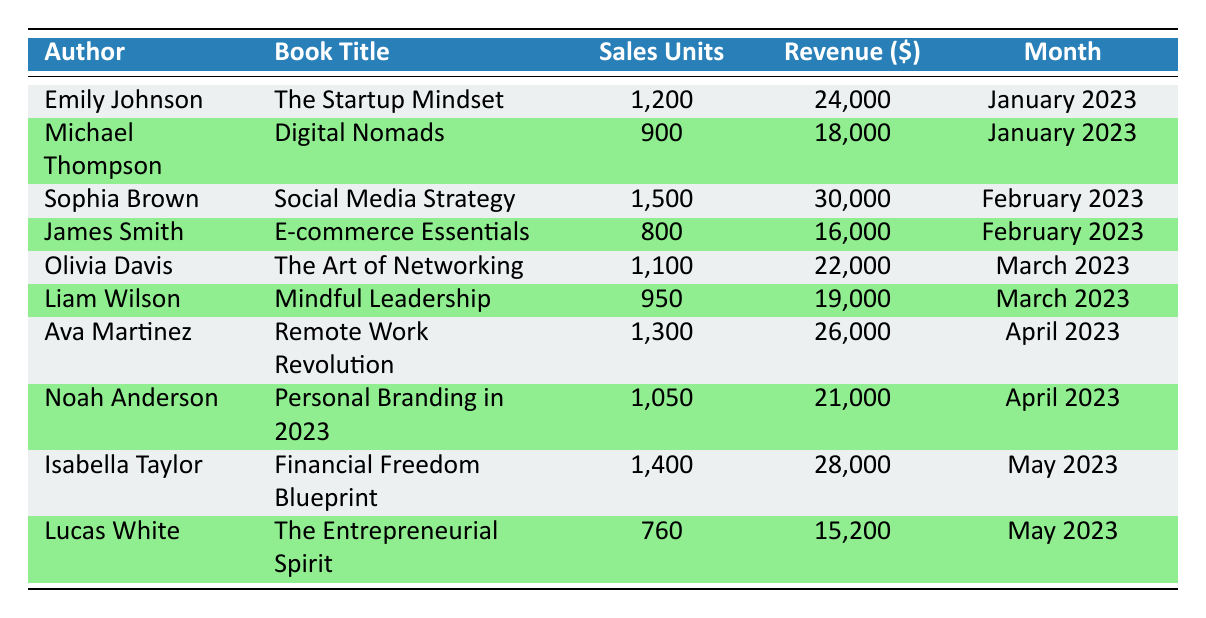What is the total revenue generated by all authors in January 2023? There are two authors in January 2023: Emily Johnson with a revenue of 24,000 and Michael Thompson with a revenue of 18,000. Adding these values gives 24,000 + 18,000 = 42,000.
Answer: 42,000 Which author had the highest sales units in February 2023? In February 2023, Sophia Brown sold 1,500 units and James Smith sold 800 units. Since 1,500 is higher than 800, Sophia Brown had the highest sales units.
Answer: Sophia Brown What is the average sales units across all months? The total sales units are 1,200 + 900 + 1,500 + 800 + 1,100 + 950 + 1,300 + 1,050 + 1,400 + 760 = 11,610. There are 10 months in total, so the average is 11,610 / 10 = 1,161.
Answer: 1,161 Did any of the books in March 2023 generate more than 20,000 in revenue? In March 2023, Olivia Davis generated 22,000 and Liam Wilson generated 19,000. Since 22,000 is greater than 20,000, yes, there was a book that generated more than 20,000.
Answer: Yes What is the total sales units for books published in April 2023 and how does it compare to February 2023? In April 2023, Ava Martinez sold 1,300 units and Noah Anderson sold 1,050 units, totaling 1,300 + 1,050 = 2,350 units. In February 2023, the total sales units were 1,500 + 800 = 2,300. Comparing both totals, 2,350 is greater than 2,300.
Answer: 2,350; greater Which month had the least revenue among the listed months? January 2023 had a revenue of 42,000, February 2023 had 46,000, March 2023 had 41,000, April 2023 had 47,000, and May 2023 had 43,200. The month with the least revenue is March 2023 with 41,000.
Answer: March 2023 Are there more authors who generated 20,000 or more in revenue than those under 20,000 across all months? Authors generating 20,000 or more in revenue: Emily Johnson, Sophia Brown, Olivia Davis, Ava Martinez, and Isabella Taylor (5 authors). Authors generating under 20,000: Michael Thompson, James Smith, Liam Wilson, Noah Anderson, and Lucas White (5 authors). They are equal, so the answer is no.
Answer: No Who had the lowest sales units in the data set? Lucas White had the lowest sales units with 760 units sold, compared to others listed.
Answer: Lucas White 